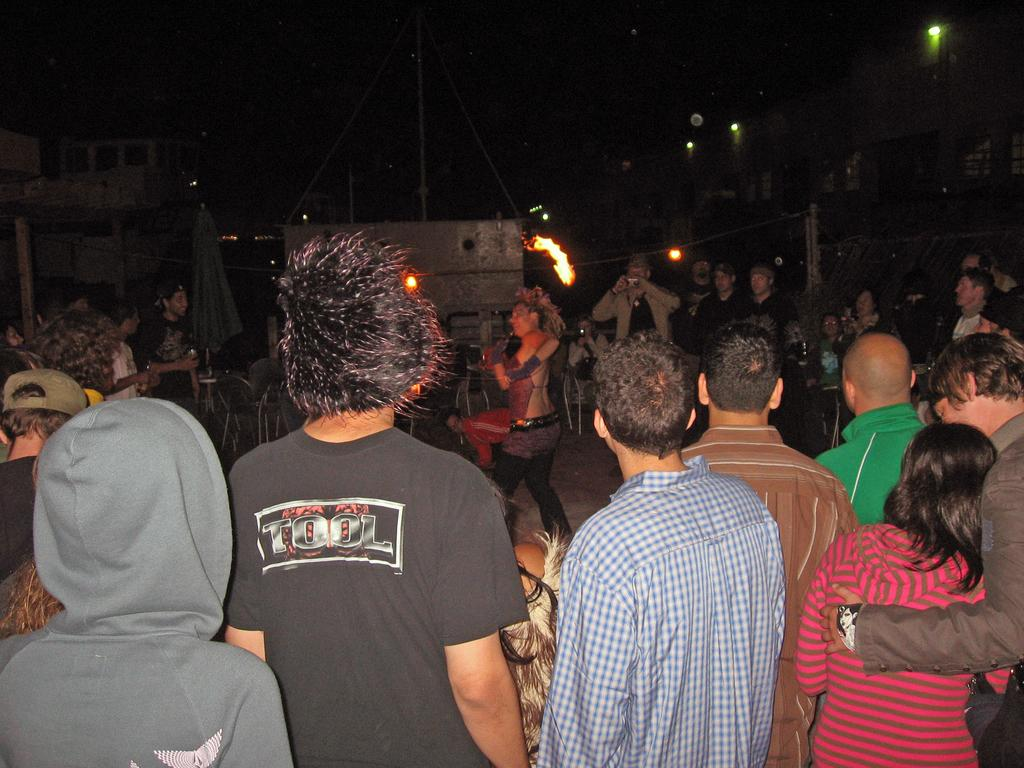How many people are in the image? There are multiple persons standing in the image. What is one person holding in the image? One person is holding a fire stick. What can be seen in the background of the image? There are houses and lights visible in the background. What type of account is being discussed by the persons in the image? There is no indication of any account being discussed in the image. Is there a printer visible in the image? There is no printer present in the image. 